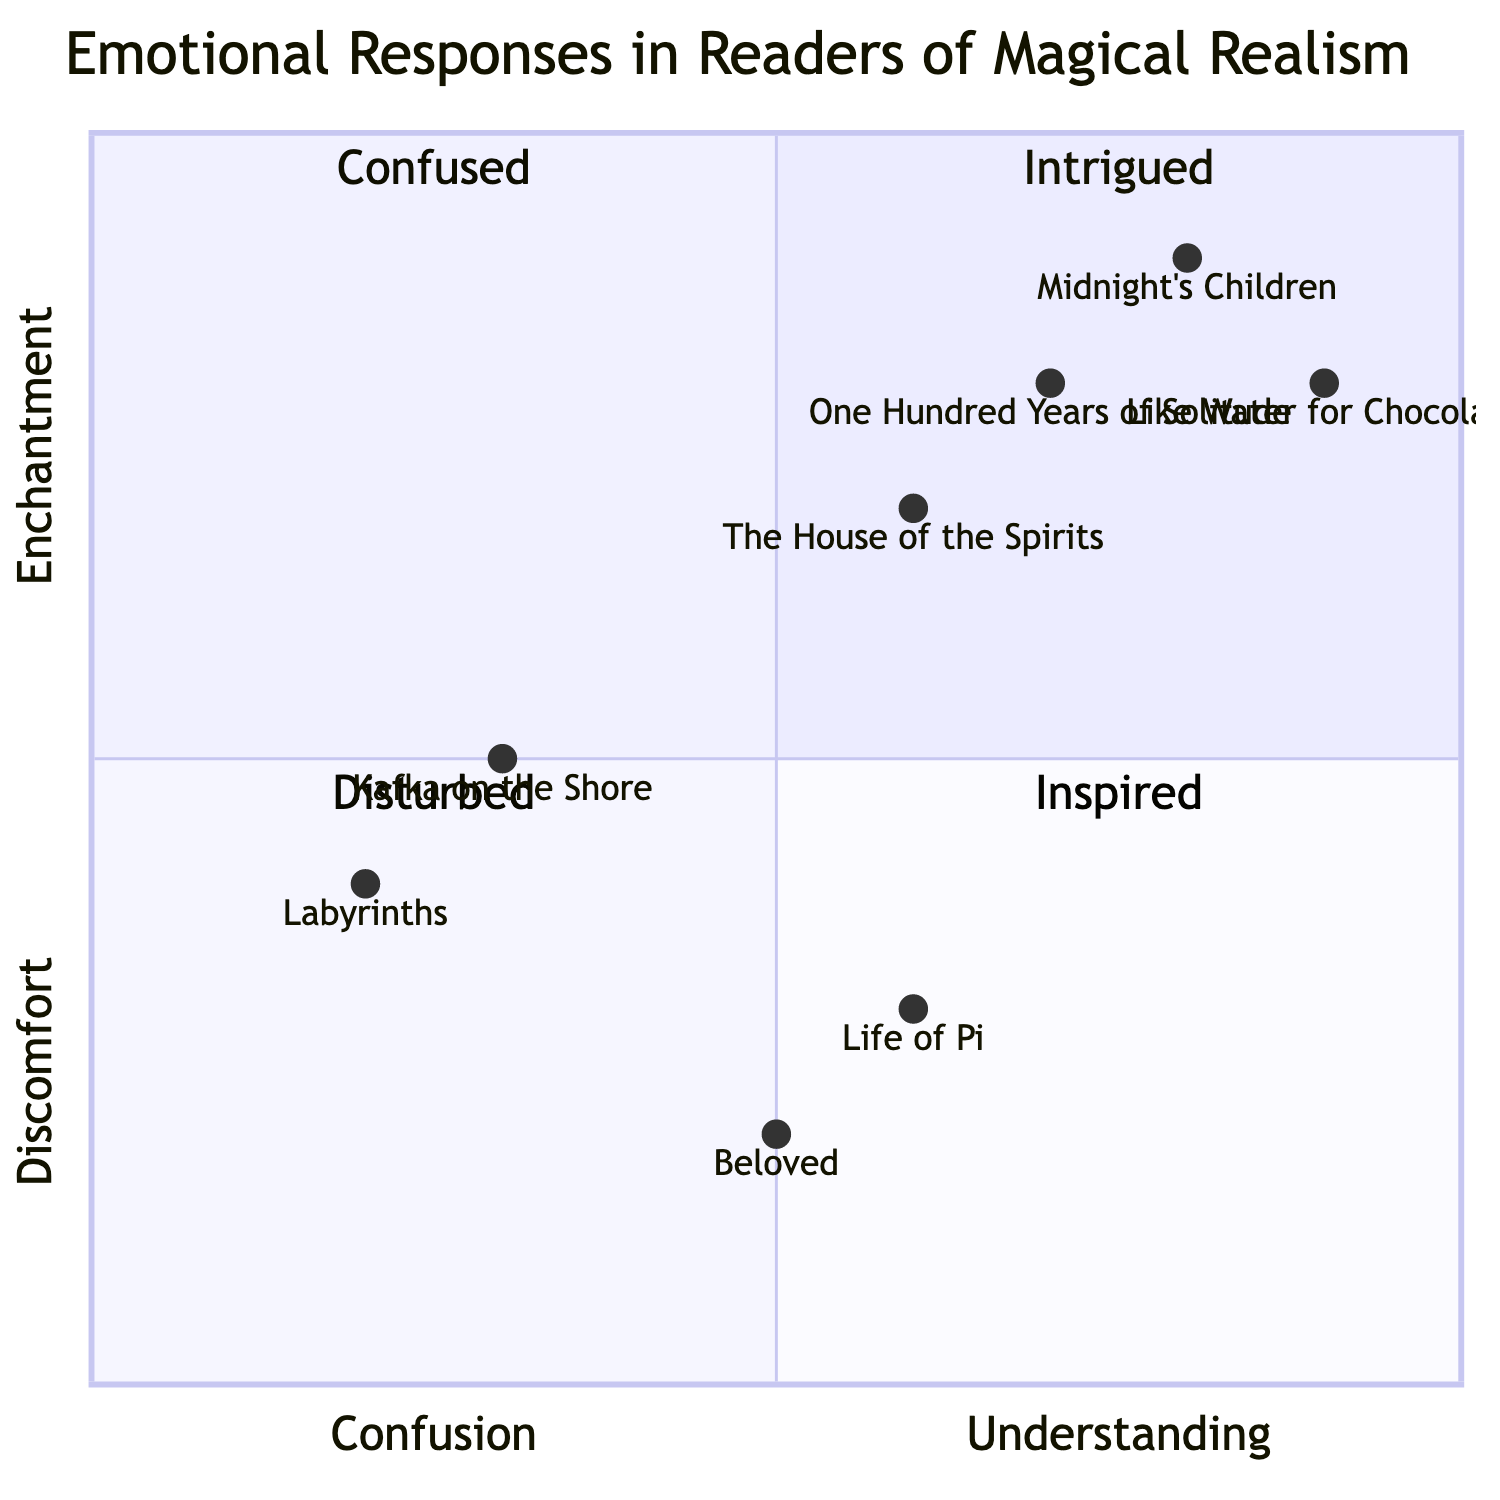What books belong to the "Intrigued" quadrant? The "Intrigued" quadrant contains two books: "One Hundred Years of Solitude" by Gabriel García Márquez and "The House of the Spirits" by Isabel Allende.
Answer: "One Hundred Years of Solitude" and "The House of the Spirits" What is the emotional response associated with "Kafka on the Shore"? "Kafka on the Shore" by Haruki Murakami is located in the "Confused" quadrant, indicating it evokes confusion in readers.
Answer: Confused Which book is positioned highest in the "Inspired" quadrant? In the "Inspired" quadrant, "Midnight's Children" by Salman Rushdie is positioned at [0.8, 0.9], making it the highest positioned book in that quadrant.
Answer: Midnight's Children How many books are represented in the "Disturbed" quadrant? The "Disturbed" quadrant contains two books: "Beloved" by Toni Morrison and "Life of Pi" by Yann Martel, totaling two books.
Answer: 2 Which book has the lowest confusion score? The book with the lowest confusion score is "Midnight's Children" with a score of 0.8 in the "Inspired" quadrant, as it is the farthest to the right on the x-axis, indicating a high level of understanding.
Answer: Midnight's Children Which quadrant has a higher emotional response: "Intrigued" or "Inspired"? The "Inspired" quadrant contains books that evoke inspiration and is higher on the y-axis (0.9 max) compared to the "Intrigued" quadrant which has the highest at (0.8 max), indicating a greater emotional response.
Answer: Inspired What is the y-axis value for "Beloved"? The y-axis value for "Beloved" is 0.2, as indicated by its position in the "Disturbed" quadrant.
Answer: 0.2 How does "Life of Pi" rank in terms of discomfort compared to "Beloved"? "Life of Pi" has a y-axis value of 0.3, which is higher than "Beloved," which has a value of 0.2, indicating that "Life of Pi" provokes more discomfort.
Answer: Higher Which book is closest to the origin of the chart? "Labyrinths" by Jorge Luis Borges is closest to the origin (0.2 on both axes) in the "Confused" quadrant, suggesting a low level of enchantment and understanding.
Answer: Labyrinths 